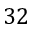<formula> <loc_0><loc_0><loc_500><loc_500>3 2</formula> 